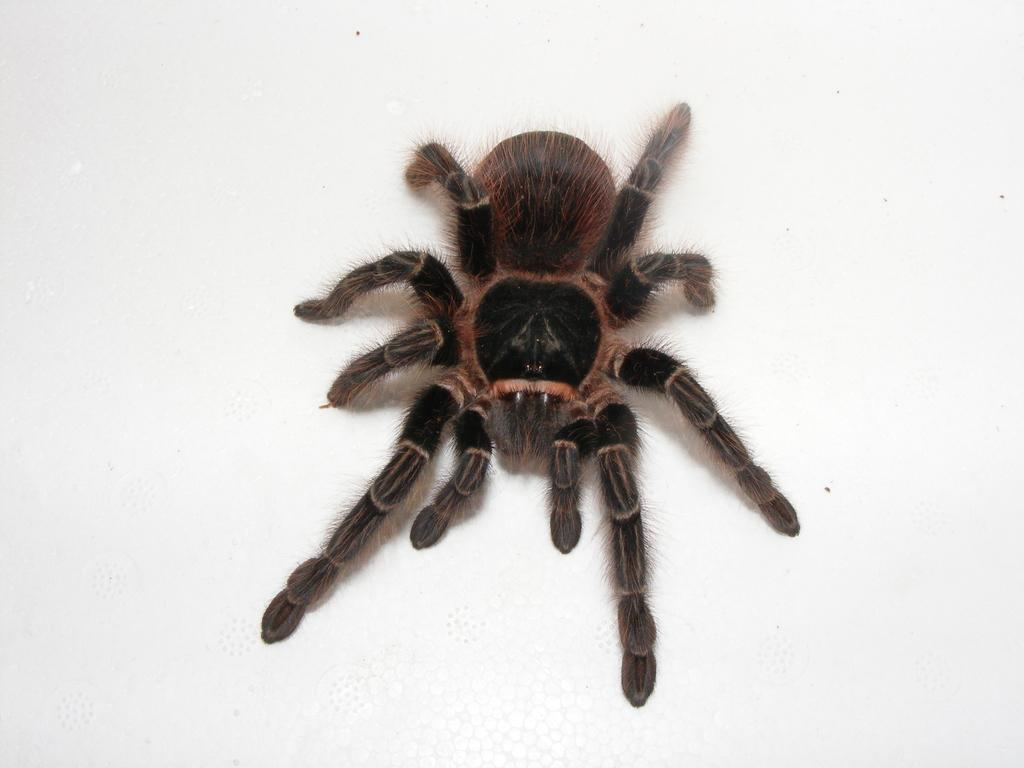What is the white-colored thing in the image? There is a white-colored thing in the image, but the specific object cannot be determined from the provided facts. What is on the white-colored thing? There is a spider on the white-colored thing. What colors does the spider have? The spider has black and brown colors. What type of cream is the spider attempting to spread on the white-colored thing? There is no cream present in the image, nor is there any indication of the spider attempting to spread anything. 